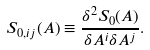Convert formula to latex. <formula><loc_0><loc_0><loc_500><loc_500>S _ { 0 , i j } ( A ) \equiv \frac { \delta ^ { 2 } S _ { 0 } ( A ) } { \delta A ^ { i } \delta A ^ { j } } .</formula> 